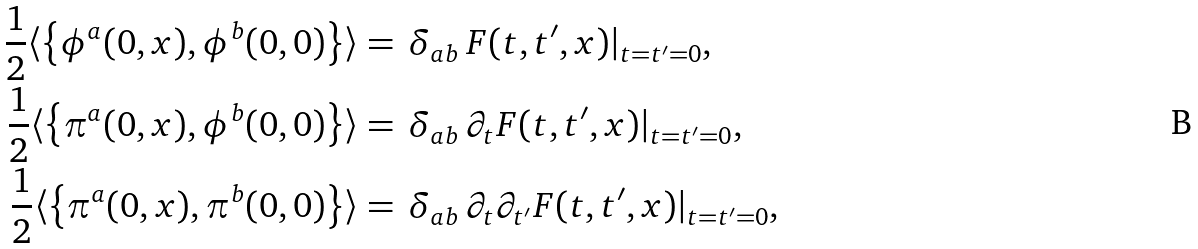Convert formula to latex. <formula><loc_0><loc_0><loc_500><loc_500>\frac { 1 } { 2 } \langle \left \{ \phi ^ { a } ( 0 , { x } ) , \phi ^ { b } ( 0 , { 0 } ) \right \} \rangle & = \, \delta _ { a b } \, F ( t , t ^ { \prime } , { x } ) | _ { t = t ^ { \prime } = 0 } , \\ \frac { 1 } { 2 } \langle \left \{ \pi ^ { a } ( 0 , { x } ) , \phi ^ { b } ( 0 , { 0 } ) \right \} \rangle & = \, \delta _ { a b } \, \partial _ { t } F ( t , t ^ { \prime } , { x } ) | _ { t = t ^ { \prime } = 0 } , \\ \frac { 1 } { 2 } \langle \left \{ \pi ^ { a } ( 0 , { x } ) , \pi ^ { b } ( 0 , { 0 } ) \right \} \rangle & = \, \delta _ { a b } \, \partial _ { t } \partial _ { t ^ { \prime } } F ( t , t ^ { \prime } , { x } ) | _ { t = t ^ { \prime } = 0 } ,</formula> 